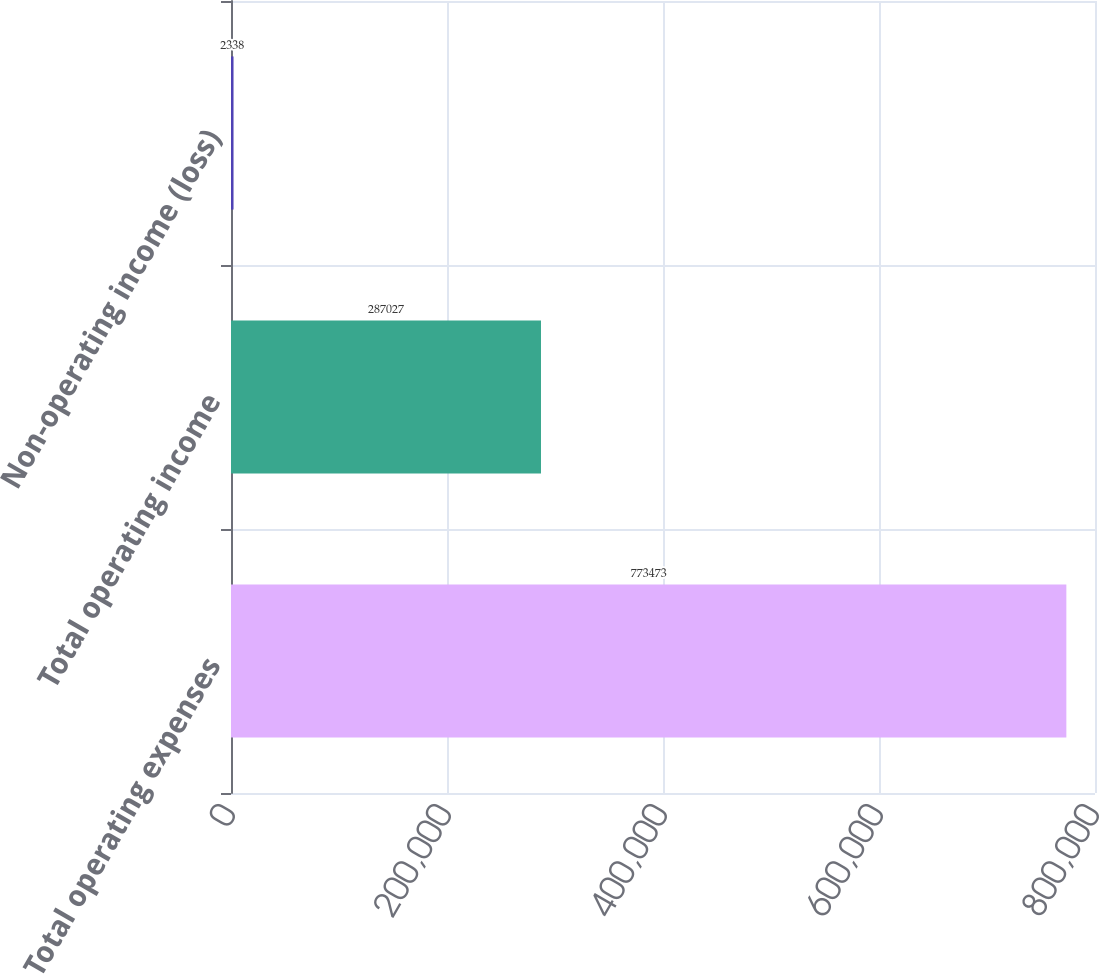Convert chart to OTSL. <chart><loc_0><loc_0><loc_500><loc_500><bar_chart><fcel>Total operating expenses<fcel>Total operating income<fcel>Non-operating income (loss)<nl><fcel>773473<fcel>287027<fcel>2338<nl></chart> 